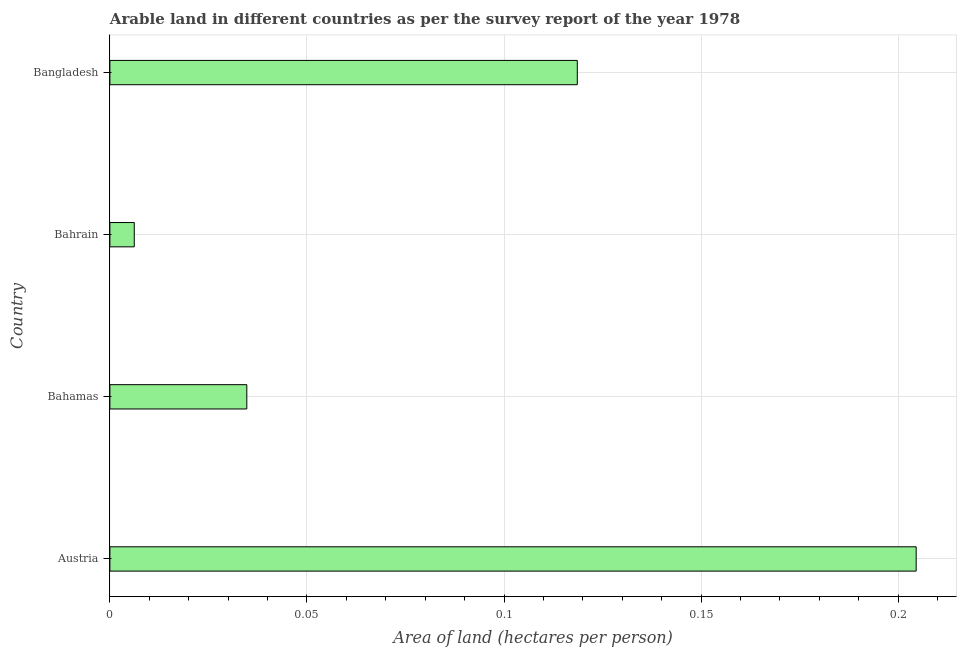Does the graph contain any zero values?
Give a very brief answer. No. Does the graph contain grids?
Ensure brevity in your answer.  Yes. What is the title of the graph?
Provide a succinct answer. Arable land in different countries as per the survey report of the year 1978. What is the label or title of the X-axis?
Offer a terse response. Area of land (hectares per person). What is the label or title of the Y-axis?
Your answer should be very brief. Country. What is the area of arable land in Austria?
Offer a terse response. 0.2. Across all countries, what is the maximum area of arable land?
Keep it short and to the point. 0.2. Across all countries, what is the minimum area of arable land?
Make the answer very short. 0.01. In which country was the area of arable land minimum?
Make the answer very short. Bahrain. What is the sum of the area of arable land?
Provide a short and direct response. 0.36. What is the difference between the area of arable land in Austria and Bangladesh?
Your answer should be very brief. 0.09. What is the average area of arable land per country?
Offer a very short reply. 0.09. What is the median area of arable land?
Your response must be concise. 0.08. In how many countries, is the area of arable land greater than 0.05 hectares per person?
Make the answer very short. 2. What is the ratio of the area of arable land in Austria to that in Bangladesh?
Give a very brief answer. 1.73. Is the difference between the area of arable land in Bahamas and Bangladesh greater than the difference between any two countries?
Offer a very short reply. No. What is the difference between the highest and the second highest area of arable land?
Your response must be concise. 0.09. Is the sum of the area of arable land in Bahamas and Bahrain greater than the maximum area of arable land across all countries?
Make the answer very short. No. In how many countries, is the area of arable land greater than the average area of arable land taken over all countries?
Give a very brief answer. 2. How many bars are there?
Provide a succinct answer. 4. How many countries are there in the graph?
Give a very brief answer. 4. What is the difference between two consecutive major ticks on the X-axis?
Provide a succinct answer. 0.05. Are the values on the major ticks of X-axis written in scientific E-notation?
Give a very brief answer. No. What is the Area of land (hectares per person) in Austria?
Provide a short and direct response. 0.2. What is the Area of land (hectares per person) of Bahamas?
Provide a succinct answer. 0.03. What is the Area of land (hectares per person) of Bahrain?
Keep it short and to the point. 0.01. What is the Area of land (hectares per person) of Bangladesh?
Your answer should be compact. 0.12. What is the difference between the Area of land (hectares per person) in Austria and Bahamas?
Offer a very short reply. 0.17. What is the difference between the Area of land (hectares per person) in Austria and Bahrain?
Keep it short and to the point. 0.2. What is the difference between the Area of land (hectares per person) in Austria and Bangladesh?
Your answer should be very brief. 0.09. What is the difference between the Area of land (hectares per person) in Bahamas and Bahrain?
Offer a very short reply. 0.03. What is the difference between the Area of land (hectares per person) in Bahamas and Bangladesh?
Your answer should be very brief. -0.08. What is the difference between the Area of land (hectares per person) in Bahrain and Bangladesh?
Keep it short and to the point. -0.11. What is the ratio of the Area of land (hectares per person) in Austria to that in Bahamas?
Keep it short and to the point. 5.89. What is the ratio of the Area of land (hectares per person) in Austria to that in Bahrain?
Ensure brevity in your answer.  33.09. What is the ratio of the Area of land (hectares per person) in Austria to that in Bangladesh?
Provide a short and direct response. 1.73. What is the ratio of the Area of land (hectares per person) in Bahamas to that in Bahrain?
Make the answer very short. 5.62. What is the ratio of the Area of land (hectares per person) in Bahamas to that in Bangladesh?
Your response must be concise. 0.29. What is the ratio of the Area of land (hectares per person) in Bahrain to that in Bangladesh?
Your response must be concise. 0.05. 